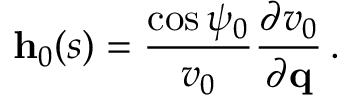<formula> <loc_0><loc_0><loc_500><loc_500>{ h } _ { 0 } ( s ) = \frac { \cos \psi _ { 0 } } { v _ { 0 } } \frac { \partial v _ { 0 } } { \partial { q } } \, .</formula> 